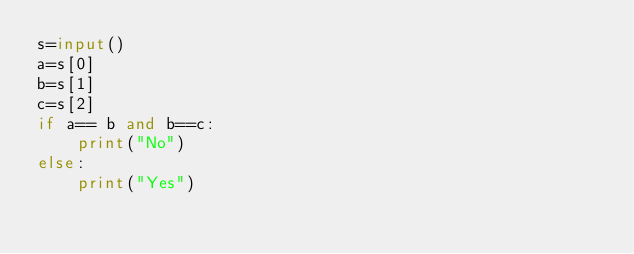Convert code to text. <code><loc_0><loc_0><loc_500><loc_500><_Python_>s=input()
a=s[0]
b=s[1]
c=s[2]
if a== b and b==c:
	print("No")
else:
	print("Yes")
 </code> 